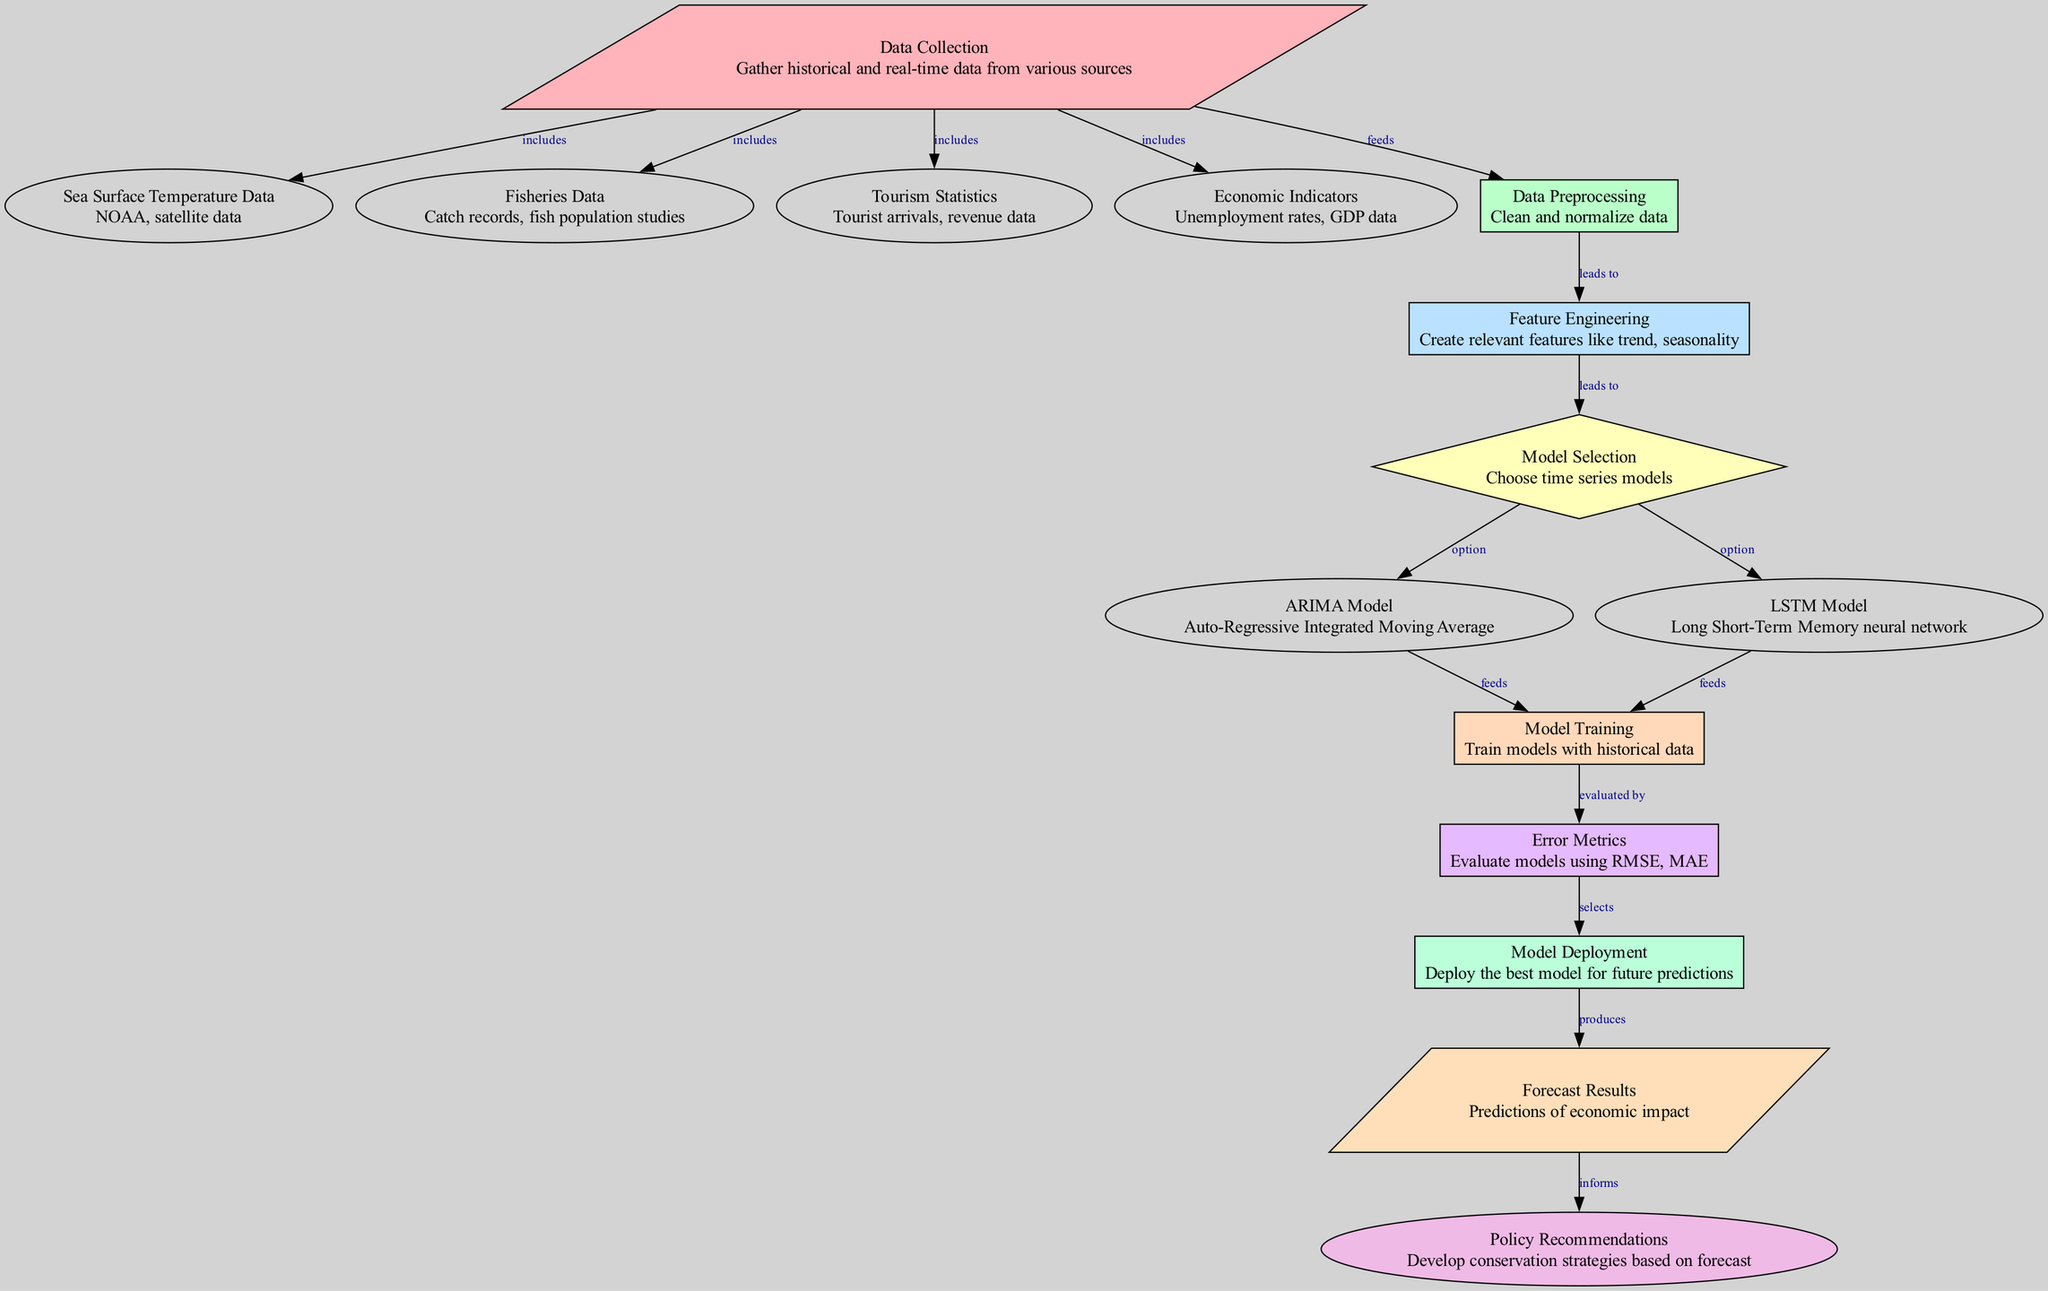What is the first step in the forecasting process? The diagram indicates that "Data Collection" is the first node, which represents the initial step needed to gather various data before any analysis can begin.
Answer: Data Collection How many total nodes are in the diagram? To find the total number of nodes, we can count all the items listed in the "nodes" section of the data provided, which amounts to 15 nodes.
Answer: 15 What is linked to "Model Selection"? The diagram shows that "Feature Engineering" is directly connected to "Model Selection," indicating that the features created precede and guide the choice of the models used for analysis.
Answer: Feature Engineering Which model is an option for time series analysis? The diagram shows two options under "Model Selection": ARIMA Model and LSTM Model, both indicated as potential methods for performing time series analysis in this context.
Answer: ARIMA Model, LSTM Model What does "Model Deployment" produce? Following "Model Deployment," the diagram indicates that this step produces "Forecast Results," which refer to the future predictions regarding the economic impact of ocean warming.
Answer: Forecast Results How does the process of "Error Metrics" relate to "Model Training"? The "Error Metrics" node is evaluated by "Model Training," which means that the performance of the trained models is assessed using specific error metrics after the training process is complete.
Answer: Evaluated by What informs "Policy Recommendations"? The diagram shows that "Forecast Results" inform "Policy Recommendations," illustrating how predictive outcomes are used to formulate conservation strategies and policies.
Answer: Forecast Results What type of data is included in "Data Collection"? The diagram indicates that "Data Collection" includes various types of data: Sea Surface Temperature Data, Fisheries Data, Tourism Statistics, and Economic Indicators, showing the diversity of data sources.
Answer: Sea Surface Temperature Data, Fisheries Data, Tourism Statistics, Economic Indicators Which step comes after "Feature Engineering"? According to the diagram, after "Feature Engineering," the next step is "Model Selection," where the data engineer chooses from various models based on the engineered features.
Answer: Model Selection 